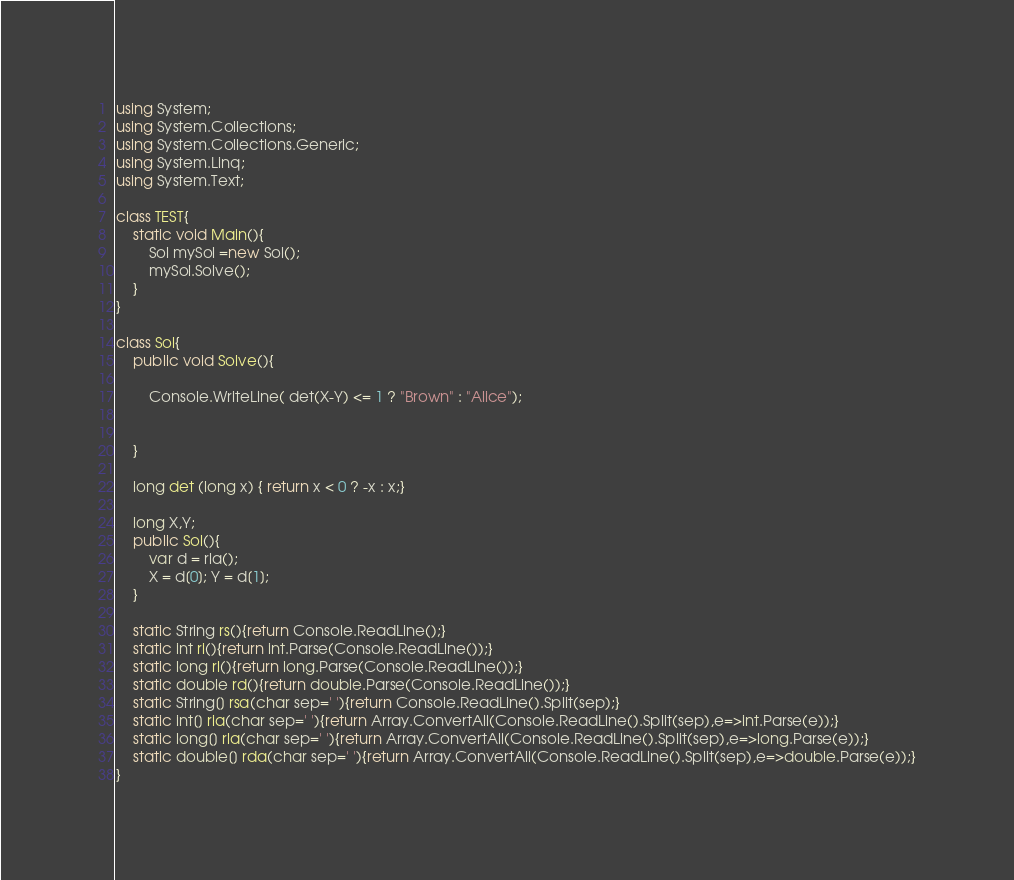<code> <loc_0><loc_0><loc_500><loc_500><_C#_>using System;
using System.Collections;
using System.Collections.Generic;
using System.Linq;
using System.Text;

class TEST{
	static void Main(){
		Sol mySol =new Sol();
		mySol.Solve();
	}
}

class Sol{
	public void Solve(){
		
		Console.WriteLine( det(X-Y) <= 1 ? "Brown" : "Alice");
		
		
	}
	
	long det (long x) { return x < 0 ? -x : x;}
	
	long X,Y;
	public Sol(){
		var d = rla();
		X = d[0]; Y = d[1];
	}

	static String rs(){return Console.ReadLine();}
	static int ri(){return int.Parse(Console.ReadLine());}
	static long rl(){return long.Parse(Console.ReadLine());}
	static double rd(){return double.Parse(Console.ReadLine());}
	static String[] rsa(char sep=' '){return Console.ReadLine().Split(sep);}
	static int[] ria(char sep=' '){return Array.ConvertAll(Console.ReadLine().Split(sep),e=>int.Parse(e));}
	static long[] rla(char sep=' '){return Array.ConvertAll(Console.ReadLine().Split(sep),e=>long.Parse(e));}
	static double[] rda(char sep=' '){return Array.ConvertAll(Console.ReadLine().Split(sep),e=>double.Parse(e));}
}
</code> 